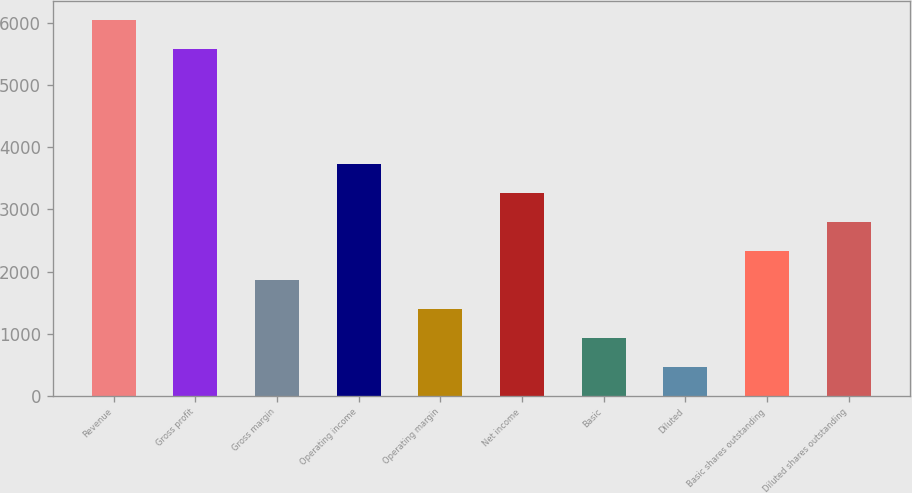<chart> <loc_0><loc_0><loc_500><loc_500><bar_chart><fcel>Revenue<fcel>Gross profit<fcel>Gross margin<fcel>Operating income<fcel>Operating margin<fcel>Net income<fcel>Basic<fcel>Diluted<fcel>Basic shares outstanding<fcel>Diluted shares outstanding<nl><fcel>6053.88<fcel>5588.24<fcel>1863.12<fcel>3725.68<fcel>1397.48<fcel>3260.04<fcel>931.84<fcel>466.2<fcel>2328.76<fcel>2794.4<nl></chart> 